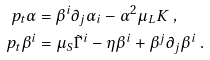<formula> <loc_0><loc_0><loc_500><loc_500>\ p _ { t } \alpha & = \beta ^ { i } \partial _ { j } \alpha _ { i } - \alpha ^ { 2 } \mu _ { L } K \ , \\ \ p _ { t } \beta ^ { i } & = \mu _ { S } \tilde { \Gamma } ^ { i } - \eta \beta ^ { i } + \beta ^ { j } \partial _ { j } \beta ^ { i } \ .</formula> 